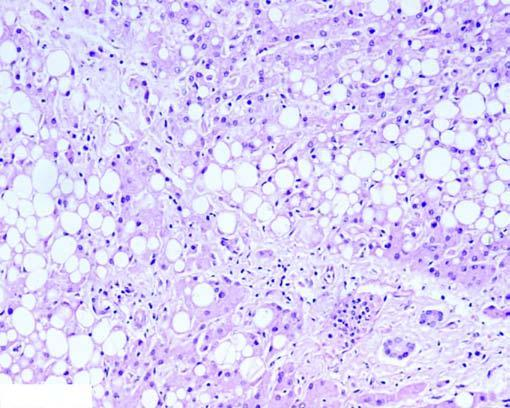do others show multiple small vacuoles in the cytoplasm (microvesicles)?
Answer the question using a single word or phrase. Yes 